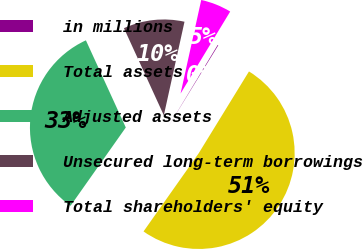<chart> <loc_0><loc_0><loc_500><loc_500><pie_chart><fcel>in millions<fcel>Total assets<fcel>Adjusted assets<fcel>Unsecured long-term borrowings<fcel>Total shareholders' equity<nl><fcel>0.11%<fcel>51.01%<fcel>33.39%<fcel>10.29%<fcel>5.2%<nl></chart> 